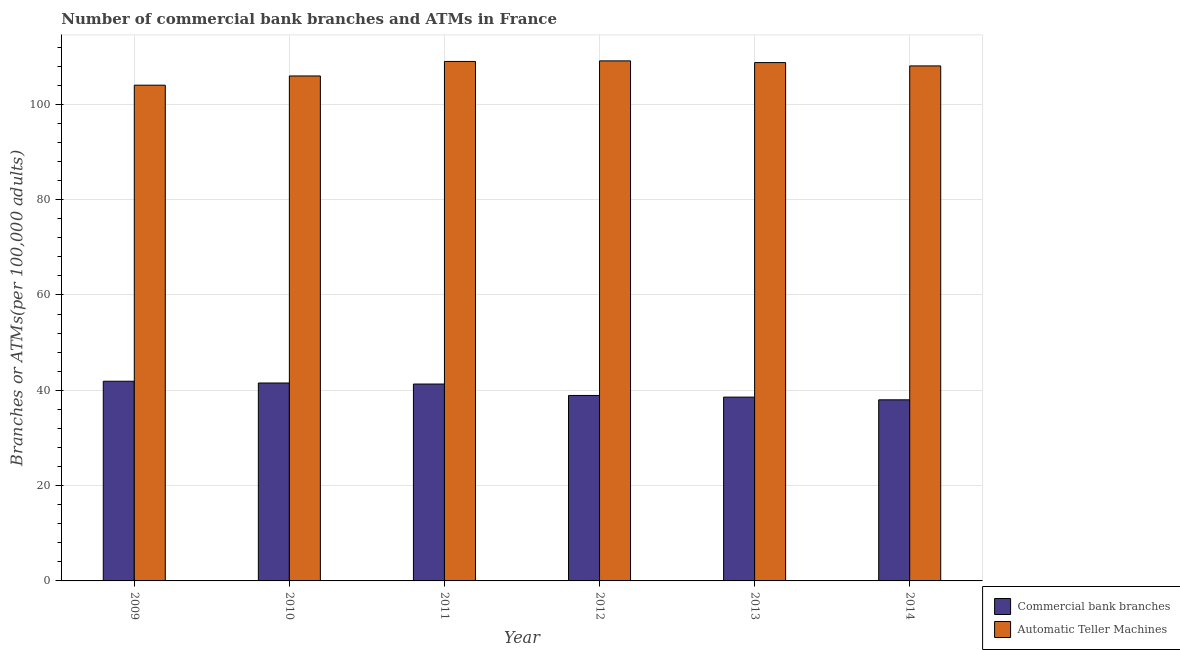How many different coloured bars are there?
Provide a short and direct response. 2. Are the number of bars on each tick of the X-axis equal?
Keep it short and to the point. Yes. How many bars are there on the 5th tick from the left?
Offer a very short reply. 2. How many bars are there on the 2nd tick from the right?
Your response must be concise. 2. What is the label of the 6th group of bars from the left?
Provide a succinct answer. 2014. What is the number of atms in 2011?
Make the answer very short. 108.99. Across all years, what is the maximum number of atms?
Keep it short and to the point. 109.11. Across all years, what is the minimum number of atms?
Offer a terse response. 104.01. In which year was the number of commercal bank branches maximum?
Provide a short and direct response. 2009. In which year was the number of commercal bank branches minimum?
Offer a very short reply. 2014. What is the total number of atms in the graph?
Your answer should be compact. 644.84. What is the difference between the number of commercal bank branches in 2011 and that in 2012?
Provide a succinct answer. 2.4. What is the difference between the number of commercal bank branches in 2009 and the number of atms in 2012?
Offer a terse response. 2.98. What is the average number of commercal bank branches per year?
Your response must be concise. 40.03. What is the ratio of the number of atms in 2010 to that in 2013?
Give a very brief answer. 0.97. Is the difference between the number of commercal bank branches in 2010 and 2014 greater than the difference between the number of atms in 2010 and 2014?
Give a very brief answer. No. What is the difference between the highest and the second highest number of atms?
Give a very brief answer. 0.12. What is the difference between the highest and the lowest number of commercal bank branches?
Ensure brevity in your answer.  3.9. What does the 2nd bar from the left in 2012 represents?
Provide a succinct answer. Automatic Teller Machines. What does the 1st bar from the right in 2011 represents?
Keep it short and to the point. Automatic Teller Machines. Are all the bars in the graph horizontal?
Keep it short and to the point. No. How many years are there in the graph?
Keep it short and to the point. 6. What is the difference between two consecutive major ticks on the Y-axis?
Your response must be concise. 20. Does the graph contain any zero values?
Your answer should be compact. No. Does the graph contain grids?
Provide a succinct answer. Yes. Where does the legend appear in the graph?
Ensure brevity in your answer.  Bottom right. How many legend labels are there?
Provide a succinct answer. 2. How are the legend labels stacked?
Offer a very short reply. Vertical. What is the title of the graph?
Make the answer very short. Number of commercial bank branches and ATMs in France. Does "GDP at market prices" appear as one of the legend labels in the graph?
Your answer should be compact. No. What is the label or title of the Y-axis?
Your answer should be very brief. Branches or ATMs(per 100,0 adults). What is the Branches or ATMs(per 100,000 adults) of Commercial bank branches in 2009?
Your answer should be compact. 41.89. What is the Branches or ATMs(per 100,000 adults) in Automatic Teller Machines in 2009?
Your answer should be compact. 104.01. What is the Branches or ATMs(per 100,000 adults) of Commercial bank branches in 2010?
Provide a short and direct response. 41.52. What is the Branches or ATMs(per 100,000 adults) of Automatic Teller Machines in 2010?
Your response must be concise. 105.94. What is the Branches or ATMs(per 100,000 adults) of Commercial bank branches in 2011?
Ensure brevity in your answer.  41.31. What is the Branches or ATMs(per 100,000 adults) of Automatic Teller Machines in 2011?
Give a very brief answer. 108.99. What is the Branches or ATMs(per 100,000 adults) in Commercial bank branches in 2012?
Offer a terse response. 38.91. What is the Branches or ATMs(per 100,000 adults) in Automatic Teller Machines in 2012?
Your answer should be very brief. 109.11. What is the Branches or ATMs(per 100,000 adults) in Commercial bank branches in 2013?
Your answer should be compact. 38.56. What is the Branches or ATMs(per 100,000 adults) in Automatic Teller Machines in 2013?
Give a very brief answer. 108.75. What is the Branches or ATMs(per 100,000 adults) of Commercial bank branches in 2014?
Make the answer very short. 38. What is the Branches or ATMs(per 100,000 adults) of Automatic Teller Machines in 2014?
Your answer should be very brief. 108.05. Across all years, what is the maximum Branches or ATMs(per 100,000 adults) in Commercial bank branches?
Give a very brief answer. 41.89. Across all years, what is the maximum Branches or ATMs(per 100,000 adults) in Automatic Teller Machines?
Ensure brevity in your answer.  109.11. Across all years, what is the minimum Branches or ATMs(per 100,000 adults) of Commercial bank branches?
Make the answer very short. 38. Across all years, what is the minimum Branches or ATMs(per 100,000 adults) of Automatic Teller Machines?
Provide a succinct answer. 104.01. What is the total Branches or ATMs(per 100,000 adults) in Commercial bank branches in the graph?
Provide a succinct answer. 240.19. What is the total Branches or ATMs(per 100,000 adults) of Automatic Teller Machines in the graph?
Offer a very short reply. 644.84. What is the difference between the Branches or ATMs(per 100,000 adults) in Commercial bank branches in 2009 and that in 2010?
Offer a very short reply. 0.37. What is the difference between the Branches or ATMs(per 100,000 adults) in Automatic Teller Machines in 2009 and that in 2010?
Your answer should be compact. -1.93. What is the difference between the Branches or ATMs(per 100,000 adults) of Commercial bank branches in 2009 and that in 2011?
Your response must be concise. 0.59. What is the difference between the Branches or ATMs(per 100,000 adults) of Automatic Teller Machines in 2009 and that in 2011?
Offer a terse response. -4.98. What is the difference between the Branches or ATMs(per 100,000 adults) of Commercial bank branches in 2009 and that in 2012?
Offer a very short reply. 2.98. What is the difference between the Branches or ATMs(per 100,000 adults) in Automatic Teller Machines in 2009 and that in 2012?
Your answer should be compact. -5.1. What is the difference between the Branches or ATMs(per 100,000 adults) in Commercial bank branches in 2009 and that in 2013?
Your response must be concise. 3.33. What is the difference between the Branches or ATMs(per 100,000 adults) in Automatic Teller Machines in 2009 and that in 2013?
Give a very brief answer. -4.74. What is the difference between the Branches or ATMs(per 100,000 adults) of Commercial bank branches in 2009 and that in 2014?
Provide a succinct answer. 3.9. What is the difference between the Branches or ATMs(per 100,000 adults) in Automatic Teller Machines in 2009 and that in 2014?
Provide a succinct answer. -4.04. What is the difference between the Branches or ATMs(per 100,000 adults) in Commercial bank branches in 2010 and that in 2011?
Offer a terse response. 0.22. What is the difference between the Branches or ATMs(per 100,000 adults) in Automatic Teller Machines in 2010 and that in 2011?
Provide a short and direct response. -3.04. What is the difference between the Branches or ATMs(per 100,000 adults) in Commercial bank branches in 2010 and that in 2012?
Offer a very short reply. 2.62. What is the difference between the Branches or ATMs(per 100,000 adults) in Automatic Teller Machines in 2010 and that in 2012?
Your answer should be compact. -3.17. What is the difference between the Branches or ATMs(per 100,000 adults) in Commercial bank branches in 2010 and that in 2013?
Give a very brief answer. 2.96. What is the difference between the Branches or ATMs(per 100,000 adults) of Automatic Teller Machines in 2010 and that in 2013?
Your answer should be compact. -2.81. What is the difference between the Branches or ATMs(per 100,000 adults) of Commercial bank branches in 2010 and that in 2014?
Provide a short and direct response. 3.53. What is the difference between the Branches or ATMs(per 100,000 adults) of Automatic Teller Machines in 2010 and that in 2014?
Ensure brevity in your answer.  -2.11. What is the difference between the Branches or ATMs(per 100,000 adults) of Commercial bank branches in 2011 and that in 2012?
Offer a terse response. 2.4. What is the difference between the Branches or ATMs(per 100,000 adults) in Automatic Teller Machines in 2011 and that in 2012?
Give a very brief answer. -0.12. What is the difference between the Branches or ATMs(per 100,000 adults) in Commercial bank branches in 2011 and that in 2013?
Your answer should be compact. 2.74. What is the difference between the Branches or ATMs(per 100,000 adults) in Automatic Teller Machines in 2011 and that in 2013?
Keep it short and to the point. 0.24. What is the difference between the Branches or ATMs(per 100,000 adults) in Commercial bank branches in 2011 and that in 2014?
Your response must be concise. 3.31. What is the difference between the Branches or ATMs(per 100,000 adults) of Automatic Teller Machines in 2011 and that in 2014?
Ensure brevity in your answer.  0.94. What is the difference between the Branches or ATMs(per 100,000 adults) of Commercial bank branches in 2012 and that in 2013?
Your answer should be very brief. 0.35. What is the difference between the Branches or ATMs(per 100,000 adults) of Automatic Teller Machines in 2012 and that in 2013?
Your response must be concise. 0.36. What is the difference between the Branches or ATMs(per 100,000 adults) in Commercial bank branches in 2012 and that in 2014?
Ensure brevity in your answer.  0.91. What is the difference between the Branches or ATMs(per 100,000 adults) of Automatic Teller Machines in 2012 and that in 2014?
Give a very brief answer. 1.06. What is the difference between the Branches or ATMs(per 100,000 adults) of Commercial bank branches in 2013 and that in 2014?
Provide a succinct answer. 0.57. What is the difference between the Branches or ATMs(per 100,000 adults) in Automatic Teller Machines in 2013 and that in 2014?
Give a very brief answer. 0.7. What is the difference between the Branches or ATMs(per 100,000 adults) of Commercial bank branches in 2009 and the Branches or ATMs(per 100,000 adults) of Automatic Teller Machines in 2010?
Give a very brief answer. -64.05. What is the difference between the Branches or ATMs(per 100,000 adults) in Commercial bank branches in 2009 and the Branches or ATMs(per 100,000 adults) in Automatic Teller Machines in 2011?
Keep it short and to the point. -67.09. What is the difference between the Branches or ATMs(per 100,000 adults) of Commercial bank branches in 2009 and the Branches or ATMs(per 100,000 adults) of Automatic Teller Machines in 2012?
Your answer should be very brief. -67.21. What is the difference between the Branches or ATMs(per 100,000 adults) of Commercial bank branches in 2009 and the Branches or ATMs(per 100,000 adults) of Automatic Teller Machines in 2013?
Give a very brief answer. -66.86. What is the difference between the Branches or ATMs(per 100,000 adults) of Commercial bank branches in 2009 and the Branches or ATMs(per 100,000 adults) of Automatic Teller Machines in 2014?
Make the answer very short. -66.16. What is the difference between the Branches or ATMs(per 100,000 adults) in Commercial bank branches in 2010 and the Branches or ATMs(per 100,000 adults) in Automatic Teller Machines in 2011?
Keep it short and to the point. -67.46. What is the difference between the Branches or ATMs(per 100,000 adults) in Commercial bank branches in 2010 and the Branches or ATMs(per 100,000 adults) in Automatic Teller Machines in 2012?
Make the answer very short. -67.58. What is the difference between the Branches or ATMs(per 100,000 adults) of Commercial bank branches in 2010 and the Branches or ATMs(per 100,000 adults) of Automatic Teller Machines in 2013?
Your response must be concise. -67.22. What is the difference between the Branches or ATMs(per 100,000 adults) in Commercial bank branches in 2010 and the Branches or ATMs(per 100,000 adults) in Automatic Teller Machines in 2014?
Offer a terse response. -66.52. What is the difference between the Branches or ATMs(per 100,000 adults) in Commercial bank branches in 2011 and the Branches or ATMs(per 100,000 adults) in Automatic Teller Machines in 2012?
Make the answer very short. -67.8. What is the difference between the Branches or ATMs(per 100,000 adults) in Commercial bank branches in 2011 and the Branches or ATMs(per 100,000 adults) in Automatic Teller Machines in 2013?
Provide a short and direct response. -67.44. What is the difference between the Branches or ATMs(per 100,000 adults) in Commercial bank branches in 2011 and the Branches or ATMs(per 100,000 adults) in Automatic Teller Machines in 2014?
Your answer should be very brief. -66.74. What is the difference between the Branches or ATMs(per 100,000 adults) of Commercial bank branches in 2012 and the Branches or ATMs(per 100,000 adults) of Automatic Teller Machines in 2013?
Provide a short and direct response. -69.84. What is the difference between the Branches or ATMs(per 100,000 adults) in Commercial bank branches in 2012 and the Branches or ATMs(per 100,000 adults) in Automatic Teller Machines in 2014?
Provide a short and direct response. -69.14. What is the difference between the Branches or ATMs(per 100,000 adults) of Commercial bank branches in 2013 and the Branches or ATMs(per 100,000 adults) of Automatic Teller Machines in 2014?
Give a very brief answer. -69.49. What is the average Branches or ATMs(per 100,000 adults) in Commercial bank branches per year?
Give a very brief answer. 40.03. What is the average Branches or ATMs(per 100,000 adults) of Automatic Teller Machines per year?
Provide a succinct answer. 107.47. In the year 2009, what is the difference between the Branches or ATMs(per 100,000 adults) of Commercial bank branches and Branches or ATMs(per 100,000 adults) of Automatic Teller Machines?
Your answer should be very brief. -62.12. In the year 2010, what is the difference between the Branches or ATMs(per 100,000 adults) in Commercial bank branches and Branches or ATMs(per 100,000 adults) in Automatic Teller Machines?
Keep it short and to the point. -64.42. In the year 2011, what is the difference between the Branches or ATMs(per 100,000 adults) of Commercial bank branches and Branches or ATMs(per 100,000 adults) of Automatic Teller Machines?
Ensure brevity in your answer.  -67.68. In the year 2012, what is the difference between the Branches or ATMs(per 100,000 adults) of Commercial bank branches and Branches or ATMs(per 100,000 adults) of Automatic Teller Machines?
Provide a short and direct response. -70.2. In the year 2013, what is the difference between the Branches or ATMs(per 100,000 adults) of Commercial bank branches and Branches or ATMs(per 100,000 adults) of Automatic Teller Machines?
Your answer should be very brief. -70.19. In the year 2014, what is the difference between the Branches or ATMs(per 100,000 adults) of Commercial bank branches and Branches or ATMs(per 100,000 adults) of Automatic Teller Machines?
Offer a very short reply. -70.05. What is the ratio of the Branches or ATMs(per 100,000 adults) in Commercial bank branches in 2009 to that in 2010?
Your answer should be very brief. 1.01. What is the ratio of the Branches or ATMs(per 100,000 adults) of Automatic Teller Machines in 2009 to that in 2010?
Provide a short and direct response. 0.98. What is the ratio of the Branches or ATMs(per 100,000 adults) in Commercial bank branches in 2009 to that in 2011?
Ensure brevity in your answer.  1.01. What is the ratio of the Branches or ATMs(per 100,000 adults) in Automatic Teller Machines in 2009 to that in 2011?
Make the answer very short. 0.95. What is the ratio of the Branches or ATMs(per 100,000 adults) in Commercial bank branches in 2009 to that in 2012?
Keep it short and to the point. 1.08. What is the ratio of the Branches or ATMs(per 100,000 adults) of Automatic Teller Machines in 2009 to that in 2012?
Make the answer very short. 0.95. What is the ratio of the Branches or ATMs(per 100,000 adults) in Commercial bank branches in 2009 to that in 2013?
Make the answer very short. 1.09. What is the ratio of the Branches or ATMs(per 100,000 adults) in Automatic Teller Machines in 2009 to that in 2013?
Give a very brief answer. 0.96. What is the ratio of the Branches or ATMs(per 100,000 adults) of Commercial bank branches in 2009 to that in 2014?
Keep it short and to the point. 1.1. What is the ratio of the Branches or ATMs(per 100,000 adults) of Automatic Teller Machines in 2009 to that in 2014?
Ensure brevity in your answer.  0.96. What is the ratio of the Branches or ATMs(per 100,000 adults) in Automatic Teller Machines in 2010 to that in 2011?
Your answer should be compact. 0.97. What is the ratio of the Branches or ATMs(per 100,000 adults) in Commercial bank branches in 2010 to that in 2012?
Your answer should be very brief. 1.07. What is the ratio of the Branches or ATMs(per 100,000 adults) of Automatic Teller Machines in 2010 to that in 2012?
Keep it short and to the point. 0.97. What is the ratio of the Branches or ATMs(per 100,000 adults) of Commercial bank branches in 2010 to that in 2013?
Offer a very short reply. 1.08. What is the ratio of the Branches or ATMs(per 100,000 adults) of Automatic Teller Machines in 2010 to that in 2013?
Give a very brief answer. 0.97. What is the ratio of the Branches or ATMs(per 100,000 adults) of Commercial bank branches in 2010 to that in 2014?
Your answer should be compact. 1.09. What is the ratio of the Branches or ATMs(per 100,000 adults) in Automatic Teller Machines in 2010 to that in 2014?
Give a very brief answer. 0.98. What is the ratio of the Branches or ATMs(per 100,000 adults) of Commercial bank branches in 2011 to that in 2012?
Offer a very short reply. 1.06. What is the ratio of the Branches or ATMs(per 100,000 adults) of Commercial bank branches in 2011 to that in 2013?
Your response must be concise. 1.07. What is the ratio of the Branches or ATMs(per 100,000 adults) of Commercial bank branches in 2011 to that in 2014?
Your response must be concise. 1.09. What is the ratio of the Branches or ATMs(per 100,000 adults) in Automatic Teller Machines in 2011 to that in 2014?
Your answer should be very brief. 1.01. What is the ratio of the Branches or ATMs(per 100,000 adults) in Commercial bank branches in 2012 to that in 2013?
Your answer should be compact. 1.01. What is the ratio of the Branches or ATMs(per 100,000 adults) of Automatic Teller Machines in 2012 to that in 2013?
Offer a terse response. 1. What is the ratio of the Branches or ATMs(per 100,000 adults) in Commercial bank branches in 2012 to that in 2014?
Offer a terse response. 1.02. What is the ratio of the Branches or ATMs(per 100,000 adults) in Automatic Teller Machines in 2012 to that in 2014?
Offer a terse response. 1.01. What is the ratio of the Branches or ATMs(per 100,000 adults) in Commercial bank branches in 2013 to that in 2014?
Provide a succinct answer. 1.01. What is the difference between the highest and the second highest Branches or ATMs(per 100,000 adults) in Commercial bank branches?
Ensure brevity in your answer.  0.37. What is the difference between the highest and the second highest Branches or ATMs(per 100,000 adults) of Automatic Teller Machines?
Keep it short and to the point. 0.12. What is the difference between the highest and the lowest Branches or ATMs(per 100,000 adults) in Commercial bank branches?
Keep it short and to the point. 3.9. What is the difference between the highest and the lowest Branches or ATMs(per 100,000 adults) of Automatic Teller Machines?
Provide a short and direct response. 5.1. 